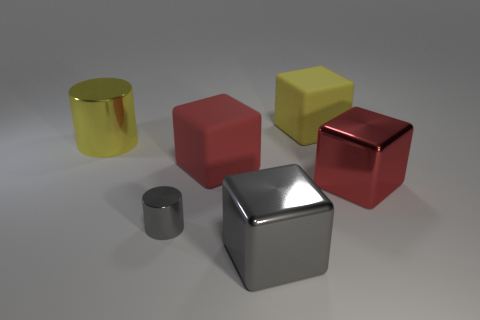How many red metallic cubes are in front of the tiny cylinder?
Provide a short and direct response. 0. There is a rubber cube right of the matte object to the left of the large yellow thing to the right of the large cylinder; what is its size?
Ensure brevity in your answer.  Large. Is there a big gray block left of the big yellow metallic cylinder that is behind the big matte cube that is left of the big gray metallic object?
Offer a very short reply. No. Are there more large yellow cylinders than metallic objects?
Keep it short and to the point. No. What is the color of the shiny cylinder behind the tiny gray object?
Give a very brief answer. Yellow. Is the number of large metal blocks that are behind the small cylinder greater than the number of big red blocks?
Keep it short and to the point. No. Do the big gray thing and the tiny object have the same material?
Provide a succinct answer. Yes. How many other objects are the same shape as the large gray object?
Offer a very short reply. 3. Is there any other thing that is made of the same material as the big yellow block?
Your response must be concise. Yes. What color is the large matte block in front of the big shiny object behind the metal cube behind the small gray thing?
Ensure brevity in your answer.  Red. 